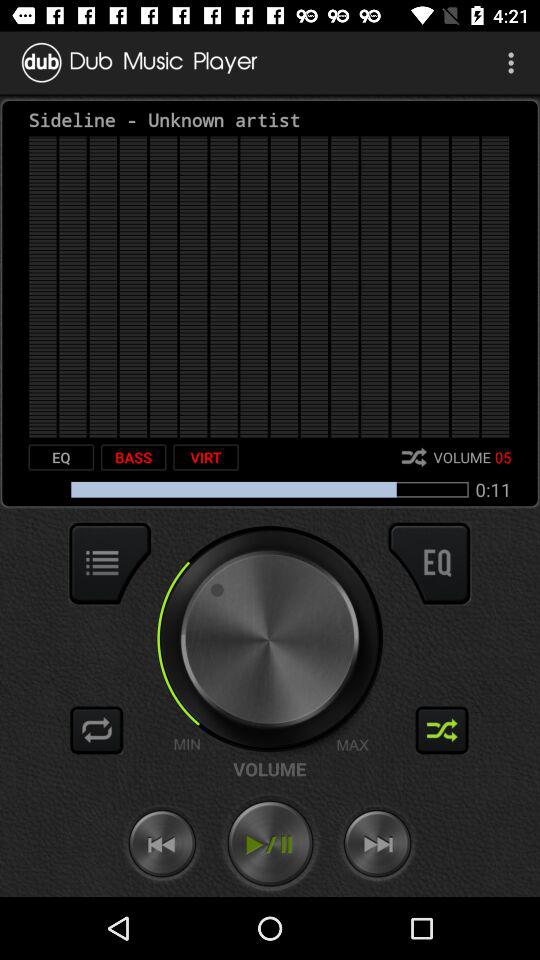What is the remaining duration of the audio? The remaining duration is 11 seconds. 